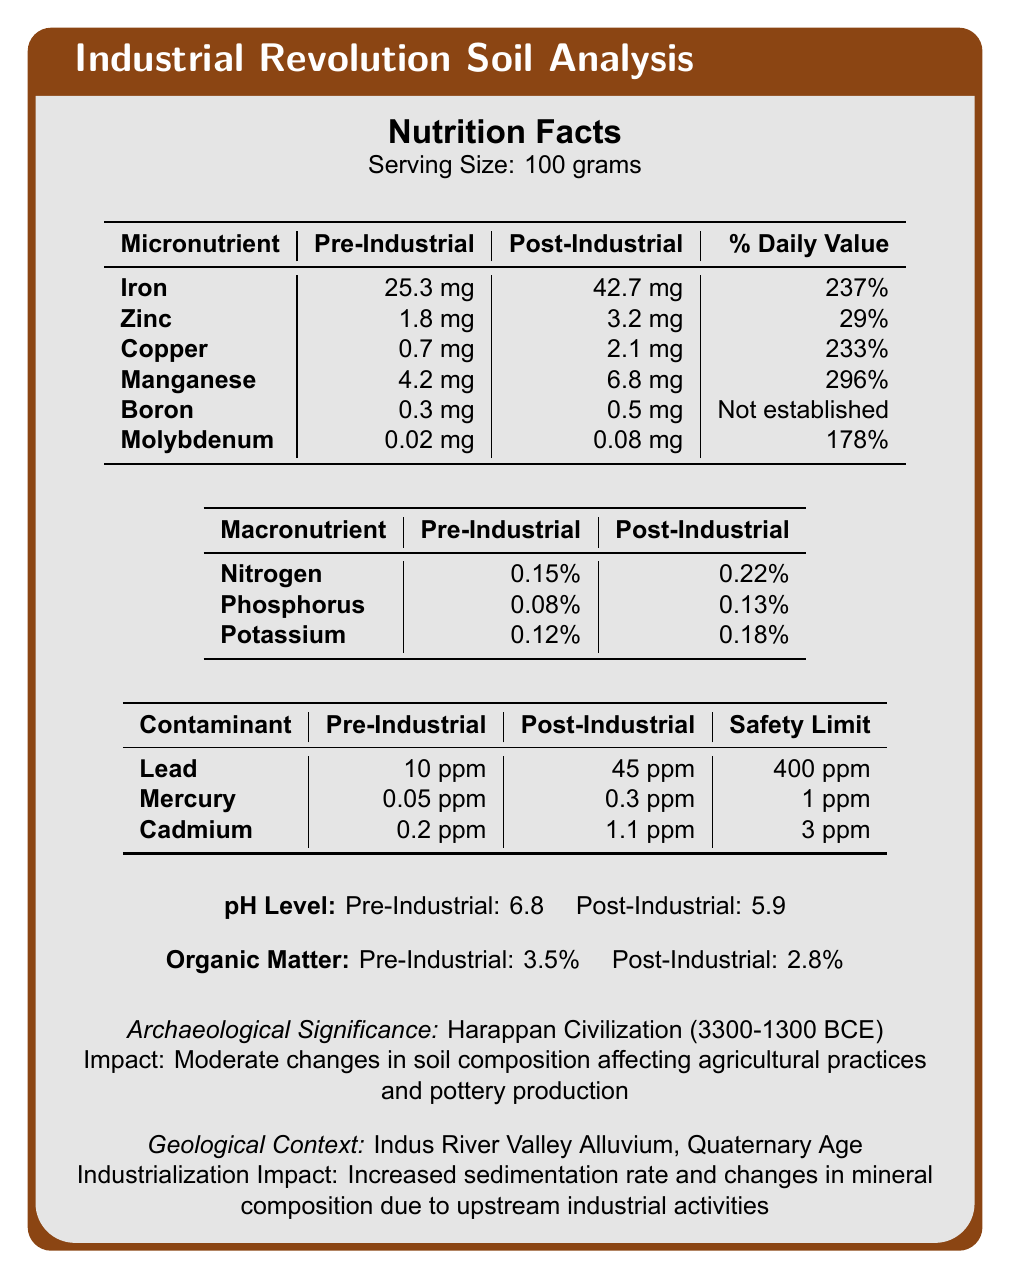what is the daily value percentage of Manganese post-industrial? According to the table under micronutrients, the daily value percentage of Manganese post-industrial is 296%.
Answer: 296% by how much did the pH level change from pre-industrial to post-industrial? The pH level dropped from 6.8 pre-industrial to 5.9 post-industrial, a change of 0.9.
Answer: 0.9 which macronutrient shows the least increase from pre-industrial to post-industrial times? Referring to the macronutrient table, Nitrogen increased from 0.15% to 0.22%, which is the smallest increase compared to Phosphorus and Potassium.
Answer: Nitrogen what is the amount of Copper in post-industrial soil samples? Copper in post-industrial soil samples is listed as 2.1 mg in the micronutrients table.
Answer: 2.1 mg how much did the organic matter content change from pre-industrial to post-industrial periods? The organic matter decreased from 3.5% pre-industrial to 2.8% post-industrial, which is a reduction of 0.7%.
Answer: 0.7% which of the following micronutrients did not see an established daily value percentage in the document? A. Iron B. Boron C. Molybdenum D. Zinc Boron is listed with "Not established" for the daily value percentage in the micronutrients table.
Answer: B what was the pre-industrial concentration of Lead in soil? A. 10 ppm B. 45 ppm C. 0.05 ppm D. 1.1 ppm According to the contaminant table, the pre-industrial concentration of Lead was 10 ppm.
Answer: A did the concentration of Mercury exceed the safety limit post-industrial? The safety limit for Mercury is 1 ppm and the post-industrial concentration is 0.3 ppm, which is below the safety limit.
Answer: No summarize the main findings of the document. The document provides a comprehensive comparison of various soil properties between pre-industrial and post-industrial periods, highlighting significant changes in nutrient and contaminant levels, and linking these changes to industrial activities and their impact on ancient civilizations and geological formations.
Answer: The document is an analysis of soil samples from pre-industrial and post-industrial periods, comparing micronutrient, macronutrient, and contaminant levels. Notable findings include increased levels of several micronutrients such as Iron and Manganese, increased macronutrient concentrations, a decrease in pH level and organic matter content, and elevated contaminant levels like Lead and Mercury. The document also notes the impact on the Harappan Civilization and geological changes caused by industrial activities. how did industrialization impact the sedimentation rate and mineral composition? The document states that there was an increase in sedimentation rate and changes in mineral composition due to upstream industrial activities but does not provide specific data or details on the extent of these changes.
Answer: Not enough information which contaminant has the highest safety limit, and how does its post-industrial concentration compare to this limit? The contaminant table shows that Lead has a safety limit of 400 ppm, and its post-industrial concentration is 45 ppm, which is well below the safety limit.
Answer: Lead, post-industrial concentration is 45 ppm compared to a safety limit of 400 ppm what impact did changes in soil composition have on the Harappan Civilization? According to the archaeological significance section, moderate changes in soil composition impacted agricultural practices and pottery production in the Harappan Civilization.
Answer: Moderate changes in soil composition affected agricultural practices and pottery production 